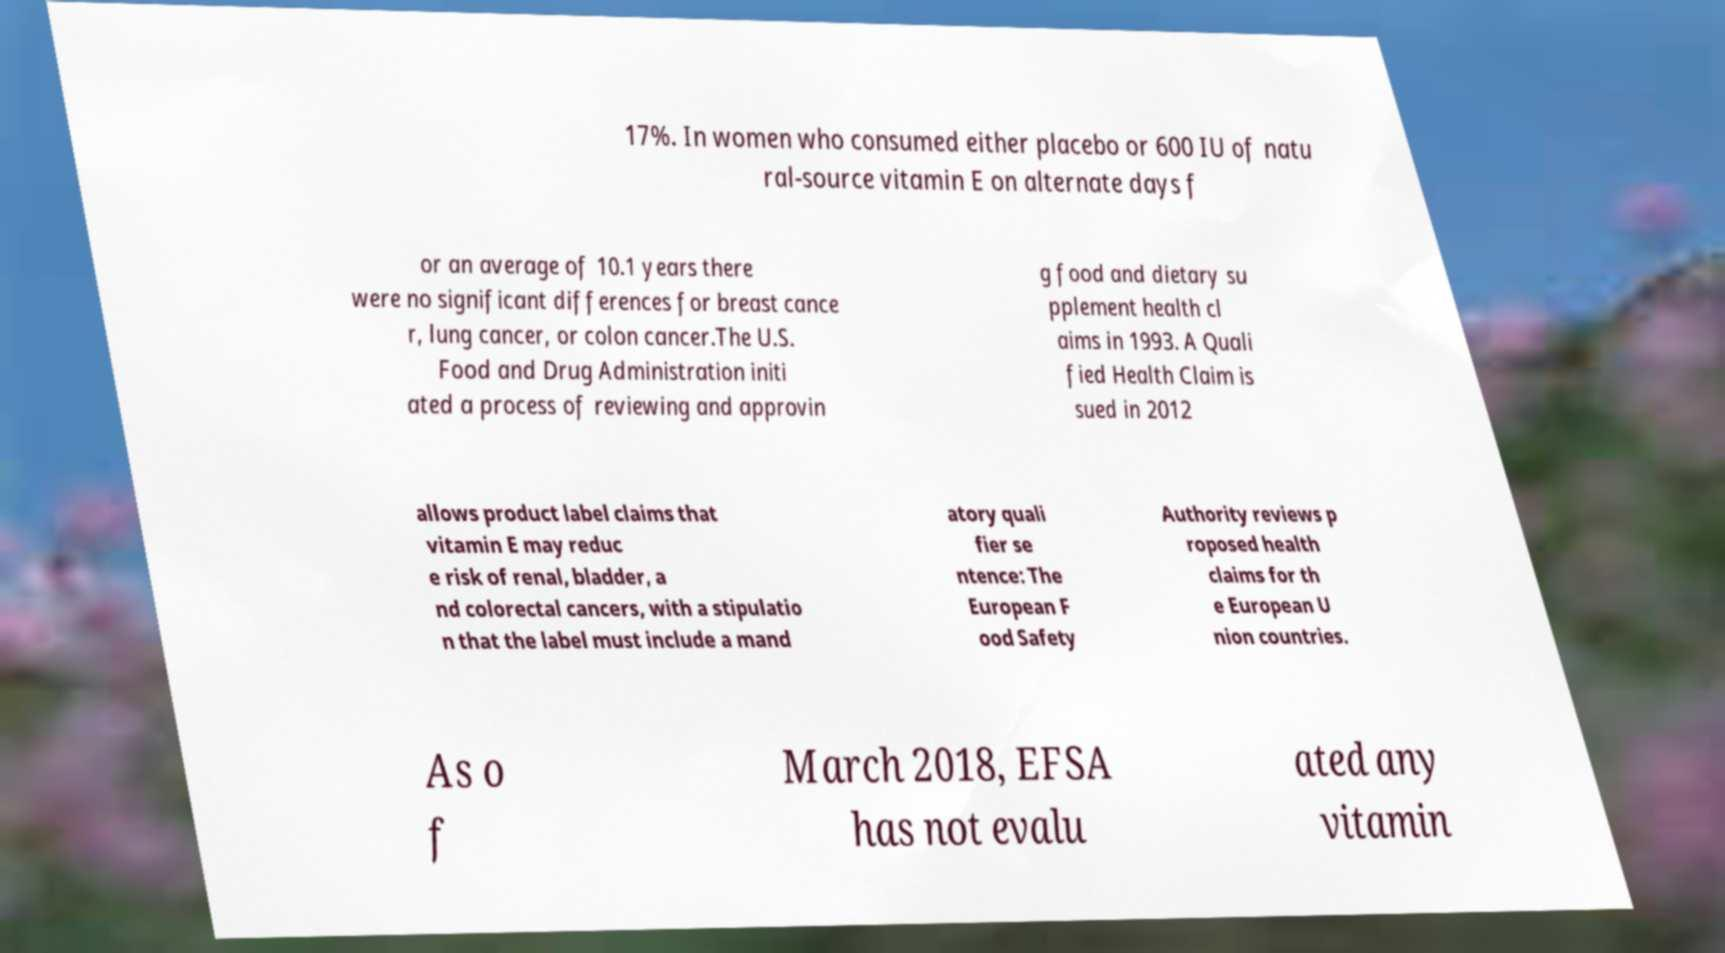For documentation purposes, I need the text within this image transcribed. Could you provide that? 17%. In women who consumed either placebo or 600 IU of natu ral-source vitamin E on alternate days f or an average of 10.1 years there were no significant differences for breast cance r, lung cancer, or colon cancer.The U.S. Food and Drug Administration initi ated a process of reviewing and approvin g food and dietary su pplement health cl aims in 1993. A Quali fied Health Claim is sued in 2012 allows product label claims that vitamin E may reduc e risk of renal, bladder, a nd colorectal cancers, with a stipulatio n that the label must include a mand atory quali fier se ntence: The European F ood Safety Authority reviews p roposed health claims for th e European U nion countries. As o f March 2018, EFSA has not evalu ated any vitamin 